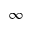<formula> <loc_0><loc_0><loc_500><loc_500>\infty</formula> 